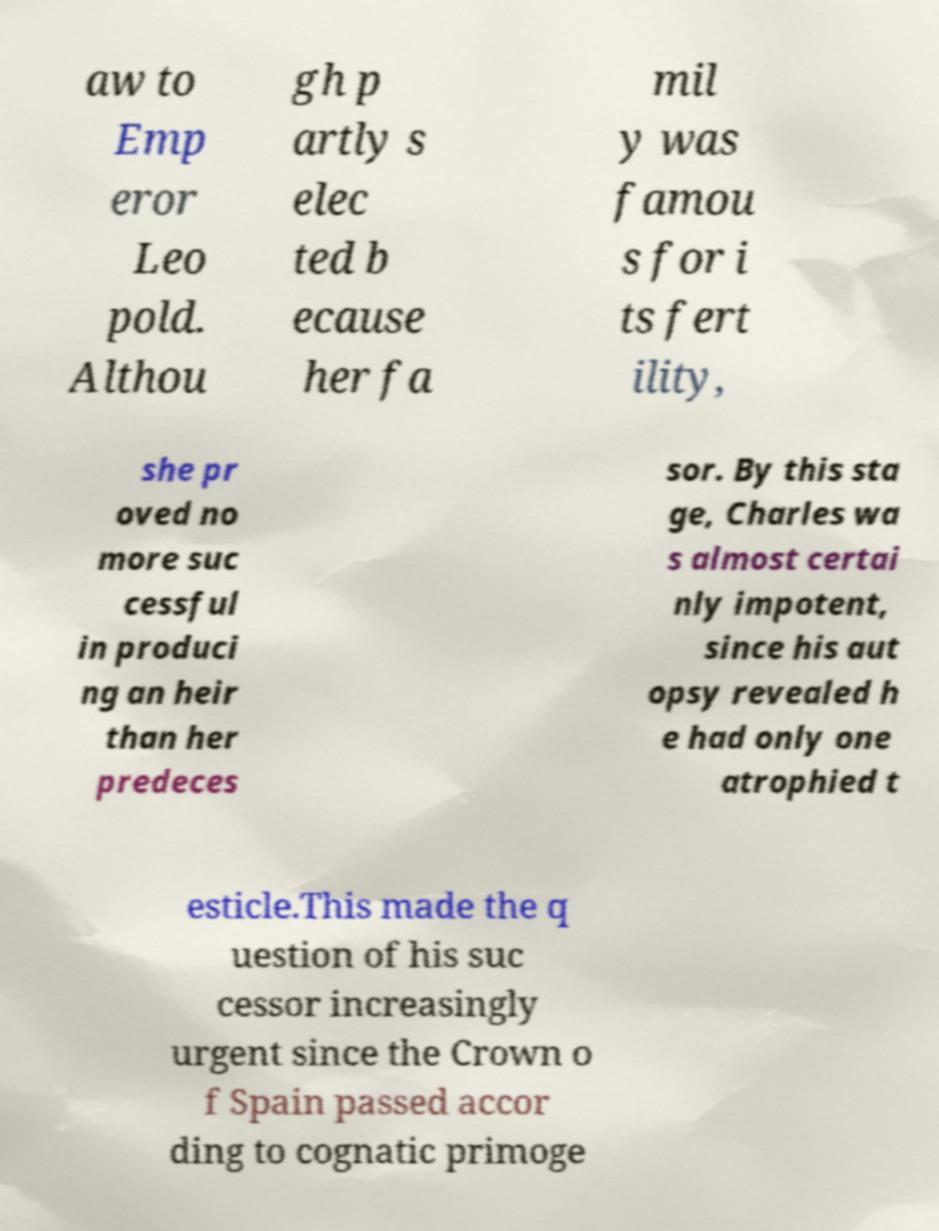What messages or text are displayed in this image? I need them in a readable, typed format. aw to Emp eror Leo pold. Althou gh p artly s elec ted b ecause her fa mil y was famou s for i ts fert ility, she pr oved no more suc cessful in produci ng an heir than her predeces sor. By this sta ge, Charles wa s almost certai nly impotent, since his aut opsy revealed h e had only one atrophied t esticle.This made the q uestion of his suc cessor increasingly urgent since the Crown o f Spain passed accor ding to cognatic primoge 